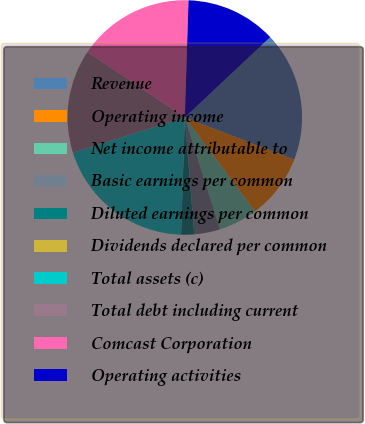Convert chart. <chart><loc_0><loc_0><loc_500><loc_500><pie_chart><fcel>Revenue<fcel>Operating income<fcel>Net income attributable to<fcel>Basic earnings per common<fcel>Diluted earnings per common<fcel>Dividends declared per common<fcel>Total assets (c)<fcel>Total debt including current<fcel>Comcast Corporation<fcel>Operating activities<nl><fcel>17.86%<fcel>8.93%<fcel>5.36%<fcel>3.57%<fcel>1.79%<fcel>0.0%<fcel>19.64%<fcel>14.29%<fcel>16.07%<fcel>12.5%<nl></chart> 